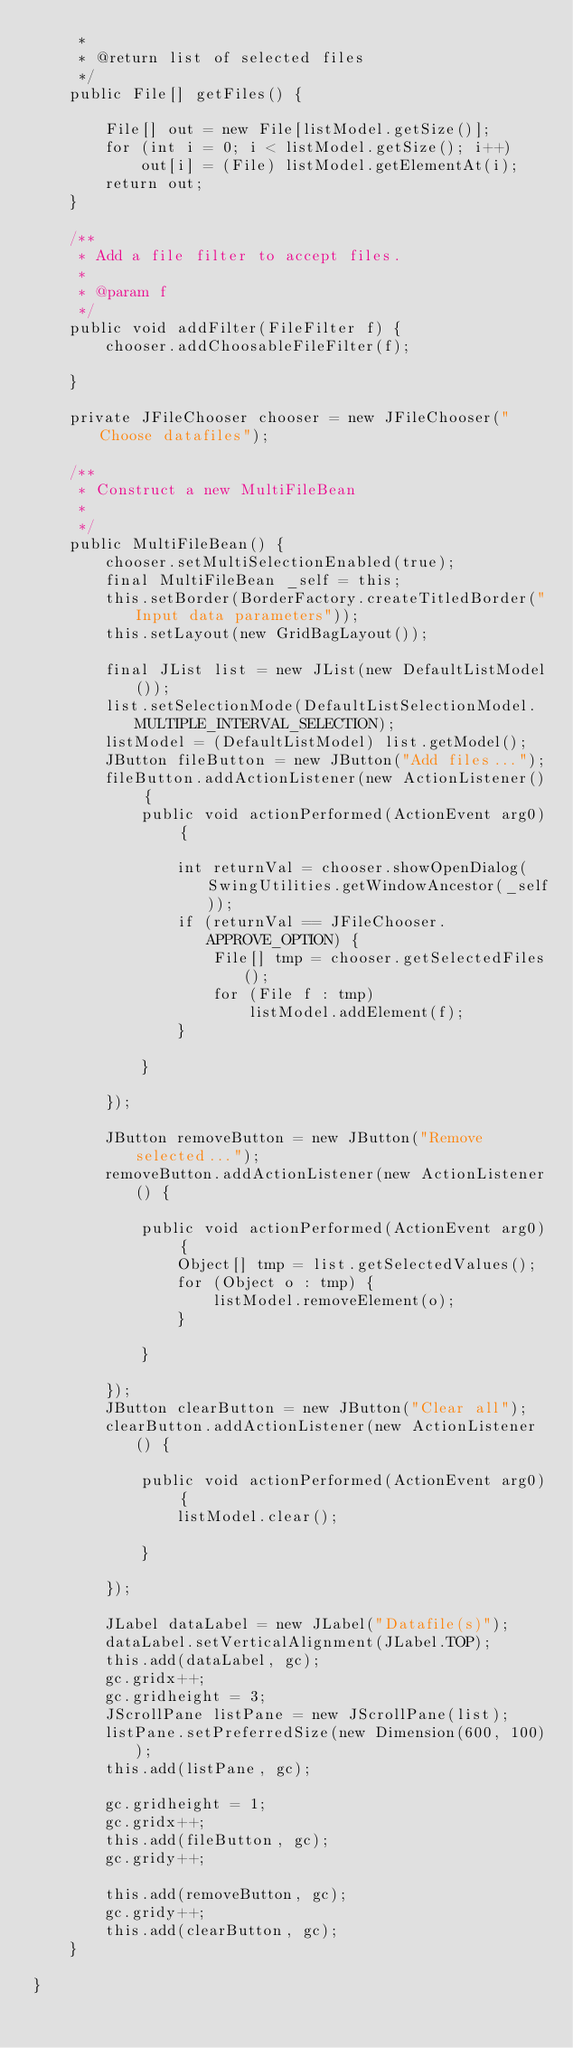<code> <loc_0><loc_0><loc_500><loc_500><_Java_>     * 
     * @return list of selected files
     */
    public File[] getFiles() {

        File[] out = new File[listModel.getSize()];
        for (int i = 0; i < listModel.getSize(); i++)
            out[i] = (File) listModel.getElementAt(i);
        return out;
    }

    /**
     * Add a file filter to accept files.
     * 
     * @param f
     */
    public void addFilter(FileFilter f) {
        chooser.addChoosableFileFilter(f);

    }

    private JFileChooser chooser = new JFileChooser("Choose datafiles");

    /**
     * Construct a new MultiFileBean
     * 
     */
    public MultiFileBean() {
        chooser.setMultiSelectionEnabled(true);
        final MultiFileBean _self = this;
        this.setBorder(BorderFactory.createTitledBorder("Input data parameters"));
        this.setLayout(new GridBagLayout());

        final JList list = new JList(new DefaultListModel());
        list.setSelectionMode(DefaultListSelectionModel.MULTIPLE_INTERVAL_SELECTION);
        listModel = (DefaultListModel) list.getModel();
        JButton fileButton = new JButton("Add files...");
        fileButton.addActionListener(new ActionListener() {
            public void actionPerformed(ActionEvent arg0) {

                int returnVal = chooser.showOpenDialog(SwingUtilities.getWindowAncestor(_self));
                if (returnVal == JFileChooser.APPROVE_OPTION) {
                    File[] tmp = chooser.getSelectedFiles();
                    for (File f : tmp)
                        listModel.addElement(f);
                }

            }

        });

        JButton removeButton = new JButton("Remove selected...");
        removeButton.addActionListener(new ActionListener() {

            public void actionPerformed(ActionEvent arg0) {
                Object[] tmp = list.getSelectedValues();
                for (Object o : tmp) {
                    listModel.removeElement(o);
                }

            }

        });
        JButton clearButton = new JButton("Clear all");
        clearButton.addActionListener(new ActionListener() {

            public void actionPerformed(ActionEvent arg0) {
                listModel.clear();

            }

        });

        JLabel dataLabel = new JLabel("Datafile(s)");
        dataLabel.setVerticalAlignment(JLabel.TOP);
        this.add(dataLabel, gc);
        gc.gridx++;
        gc.gridheight = 3;
        JScrollPane listPane = new JScrollPane(list);
        listPane.setPreferredSize(new Dimension(600, 100));
        this.add(listPane, gc);

        gc.gridheight = 1;
        gc.gridx++;
        this.add(fileButton, gc);
        gc.gridy++;

        this.add(removeButton, gc);
        gc.gridy++;
        this.add(clearButton, gc);
    }

}
</code> 